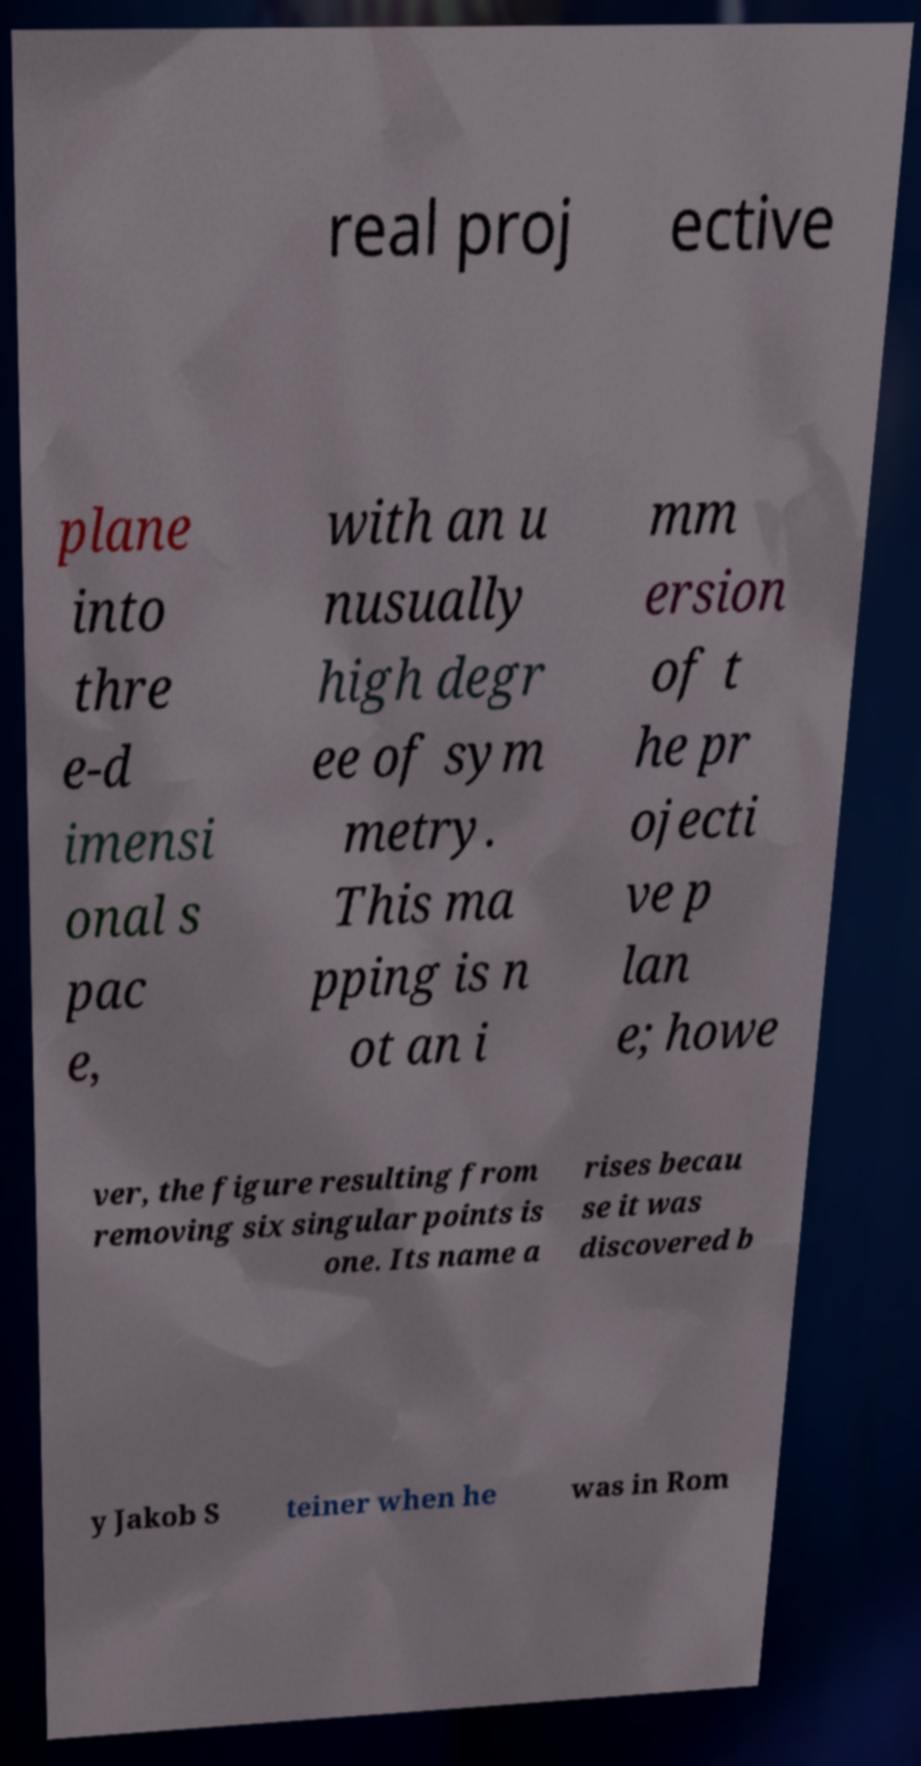Could you extract and type out the text from this image? real proj ective plane into thre e-d imensi onal s pac e, with an u nusually high degr ee of sym metry. This ma pping is n ot an i mm ersion of t he pr ojecti ve p lan e; howe ver, the figure resulting from removing six singular points is one. Its name a rises becau se it was discovered b y Jakob S teiner when he was in Rom 